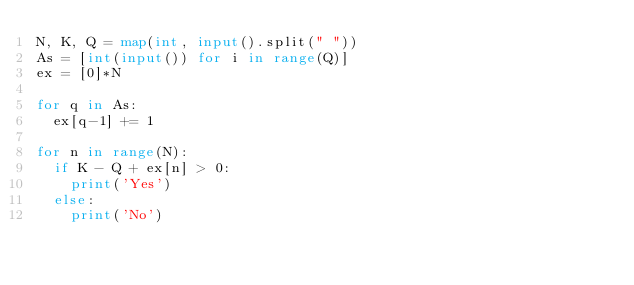<code> <loc_0><loc_0><loc_500><loc_500><_Python_>N, K, Q = map(int, input().split(" "))
As = [int(input()) for i in range(Q)] 
ex = [0]*N

for q in As:
  ex[q-1] += 1

for n in range(N):
  if K - Q + ex[n] > 0:
    print('Yes')
  else:
    print('No')</code> 